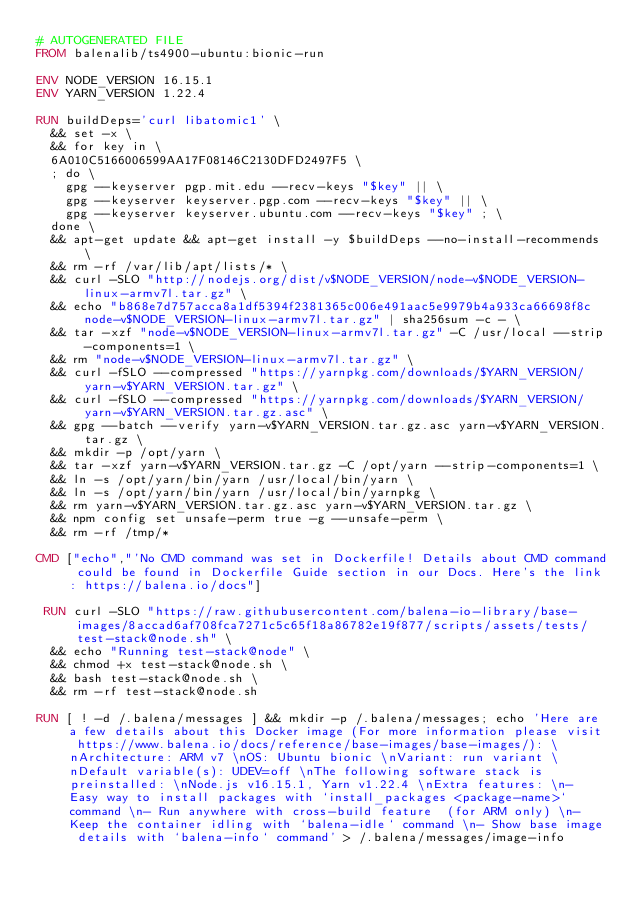Convert code to text. <code><loc_0><loc_0><loc_500><loc_500><_Dockerfile_># AUTOGENERATED FILE
FROM balenalib/ts4900-ubuntu:bionic-run

ENV NODE_VERSION 16.15.1
ENV YARN_VERSION 1.22.4

RUN buildDeps='curl libatomic1' \
	&& set -x \
	&& for key in \
	6A010C5166006599AA17F08146C2130DFD2497F5 \
	; do \
		gpg --keyserver pgp.mit.edu --recv-keys "$key" || \
		gpg --keyserver keyserver.pgp.com --recv-keys "$key" || \
		gpg --keyserver keyserver.ubuntu.com --recv-keys "$key" ; \
	done \
	&& apt-get update && apt-get install -y $buildDeps --no-install-recommends \
	&& rm -rf /var/lib/apt/lists/* \
	&& curl -SLO "http://nodejs.org/dist/v$NODE_VERSION/node-v$NODE_VERSION-linux-armv7l.tar.gz" \
	&& echo "b868e7d757acca8a1df5394f2381365c006e491aac5e9979b4a933ca66698f8c  node-v$NODE_VERSION-linux-armv7l.tar.gz" | sha256sum -c - \
	&& tar -xzf "node-v$NODE_VERSION-linux-armv7l.tar.gz" -C /usr/local --strip-components=1 \
	&& rm "node-v$NODE_VERSION-linux-armv7l.tar.gz" \
	&& curl -fSLO --compressed "https://yarnpkg.com/downloads/$YARN_VERSION/yarn-v$YARN_VERSION.tar.gz" \
	&& curl -fSLO --compressed "https://yarnpkg.com/downloads/$YARN_VERSION/yarn-v$YARN_VERSION.tar.gz.asc" \
	&& gpg --batch --verify yarn-v$YARN_VERSION.tar.gz.asc yarn-v$YARN_VERSION.tar.gz \
	&& mkdir -p /opt/yarn \
	&& tar -xzf yarn-v$YARN_VERSION.tar.gz -C /opt/yarn --strip-components=1 \
	&& ln -s /opt/yarn/bin/yarn /usr/local/bin/yarn \
	&& ln -s /opt/yarn/bin/yarn /usr/local/bin/yarnpkg \
	&& rm yarn-v$YARN_VERSION.tar.gz.asc yarn-v$YARN_VERSION.tar.gz \
	&& npm config set unsafe-perm true -g --unsafe-perm \
	&& rm -rf /tmp/*

CMD ["echo","'No CMD command was set in Dockerfile! Details about CMD command could be found in Dockerfile Guide section in our Docs. Here's the link: https://balena.io/docs"]

 RUN curl -SLO "https://raw.githubusercontent.com/balena-io-library/base-images/8accad6af708fca7271c5c65f18a86782e19f877/scripts/assets/tests/test-stack@node.sh" \
  && echo "Running test-stack@node" \
  && chmod +x test-stack@node.sh \
  && bash test-stack@node.sh \
  && rm -rf test-stack@node.sh 

RUN [ ! -d /.balena/messages ] && mkdir -p /.balena/messages; echo 'Here are a few details about this Docker image (For more information please visit https://www.balena.io/docs/reference/base-images/base-images/): \nArchitecture: ARM v7 \nOS: Ubuntu bionic \nVariant: run variant \nDefault variable(s): UDEV=off \nThe following software stack is preinstalled: \nNode.js v16.15.1, Yarn v1.22.4 \nExtra features: \n- Easy way to install packages with `install_packages <package-name>` command \n- Run anywhere with cross-build feature  (for ARM only) \n- Keep the container idling with `balena-idle` command \n- Show base image details with `balena-info` command' > /.balena/messages/image-info</code> 